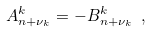Convert formula to latex. <formula><loc_0><loc_0><loc_500><loc_500>A _ { n + \nu _ { k } } ^ { k } = - B _ { n + \nu _ { k } } ^ { k } \ ,</formula> 